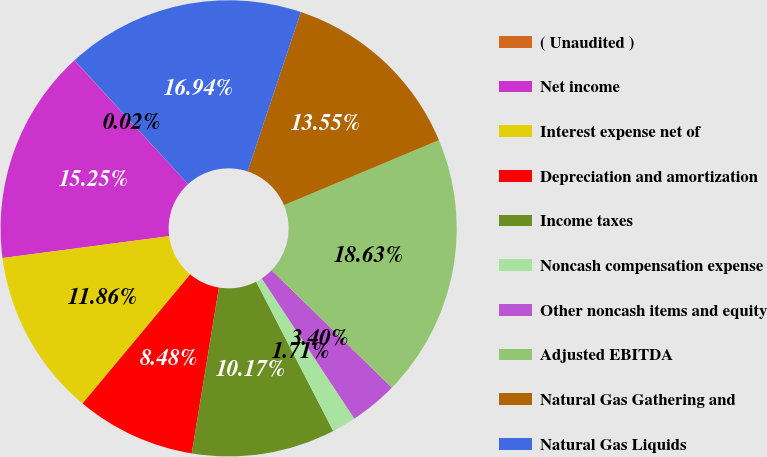Convert chart to OTSL. <chart><loc_0><loc_0><loc_500><loc_500><pie_chart><fcel>( Unaudited )<fcel>Net income<fcel>Interest expense net of<fcel>Depreciation and amortization<fcel>Income taxes<fcel>Noncash compensation expense<fcel>Other noncash items and equity<fcel>Adjusted EBITDA<fcel>Natural Gas Gathering and<fcel>Natural Gas Liquids<nl><fcel>0.02%<fcel>15.25%<fcel>11.86%<fcel>8.48%<fcel>10.17%<fcel>1.71%<fcel>3.4%<fcel>18.63%<fcel>13.55%<fcel>16.94%<nl></chart> 